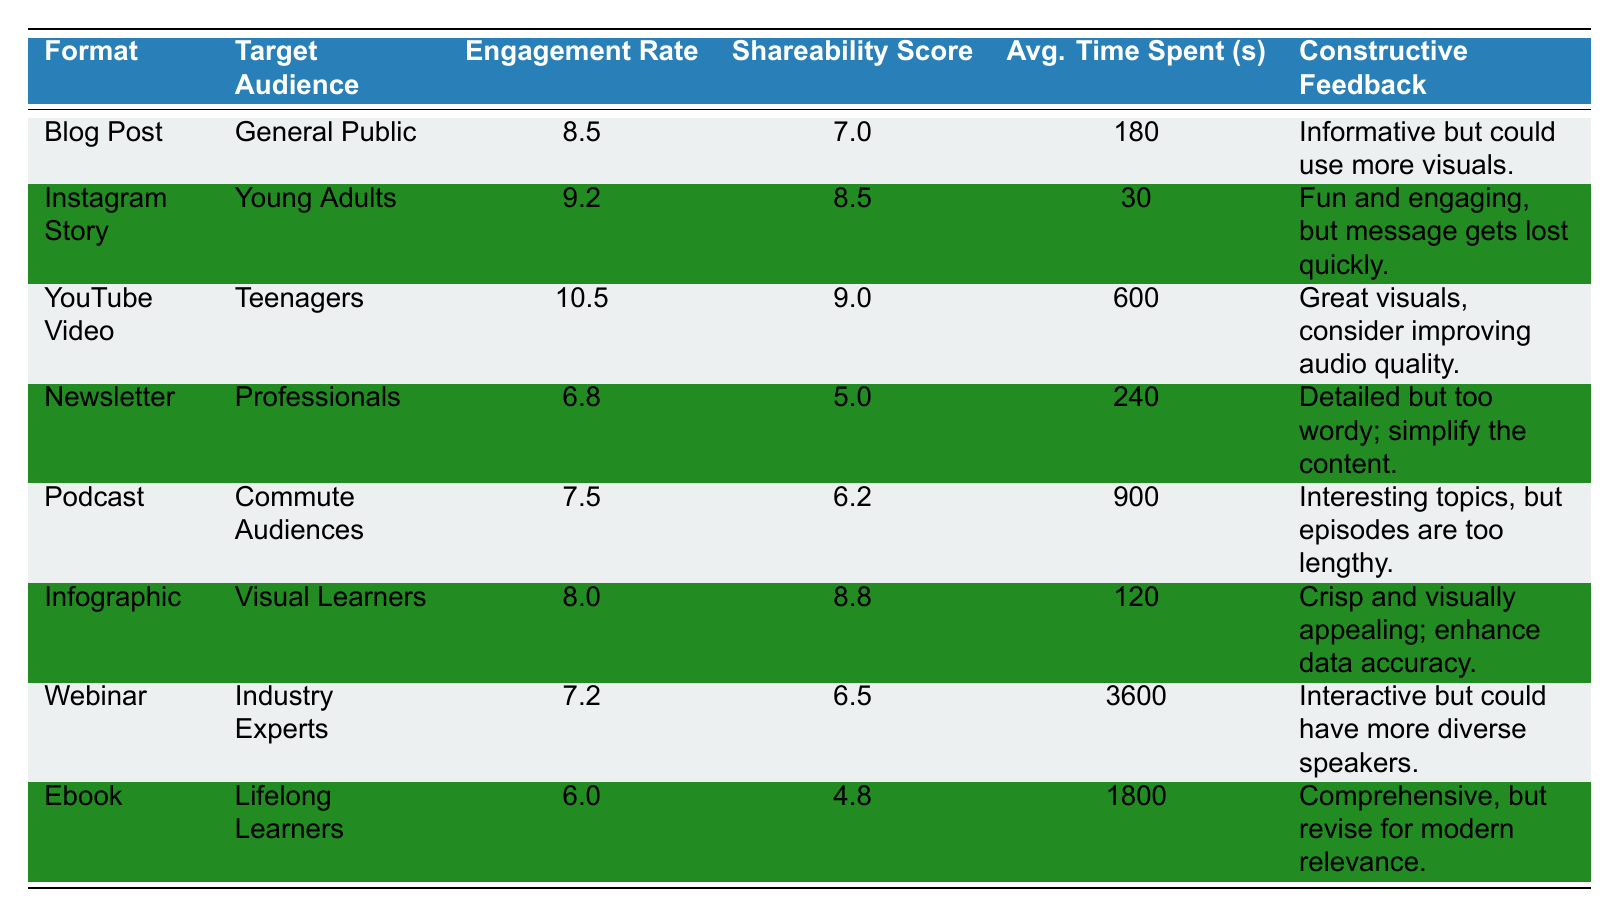What is the engagement rate of the YouTube Video? The YouTube Video row shows an engagement rate of 10.5 in the corresponding column.
Answer: 10.5 Which creative content format has the lowest shareability score? Looking at the shareability score column, the Newsletter has the lowest score of 5.0 among all formats listed.
Answer: Newsletter Is the average time spent on the Webinar greater than that on the Podcast? The average time spent on the Webinar is 3600 seconds, while the Podcast is 900 seconds. Since 3600 is greater than 900, the answer is yes.
Answer: Yes What is the average engagement rate of content formats targeting the General Public and Young Adults? The engagement rates for the Blog Post (8.5) and Instagram Story (9.2) need to be added together: 8.5 + 9.2 = 17.7. Divide that sum by 2 to get the average: 17.7 / 2 = 8.85.
Answer: 8.85 How many creative content formats have an engagement rate above 8? The Blog Post (8.5), Instagram Story (9.2), and YouTube Video (10.5) have engagement rates above 8. In total, there are three formats.
Answer: 3 Which format has the highest average time spent and what is that time? The Webinar has the highest average time spent at 3600 seconds, as indicated in the average time spent column.
Answer: 3600 seconds Is it true that the Podcast has a shareability score lower than 7? The Podcast's shareability score is 6.2, which is indeed lower than 7. Therefore, the statement is true.
Answer: True What is the sum of average time spent for both the Blog Post and Infographic? The average time spent for the Blog Post is 180 seconds and for the Infographic it is 120 seconds. Summing those gives: 180 + 120 = 300 seconds.
Answer: 300 seconds 